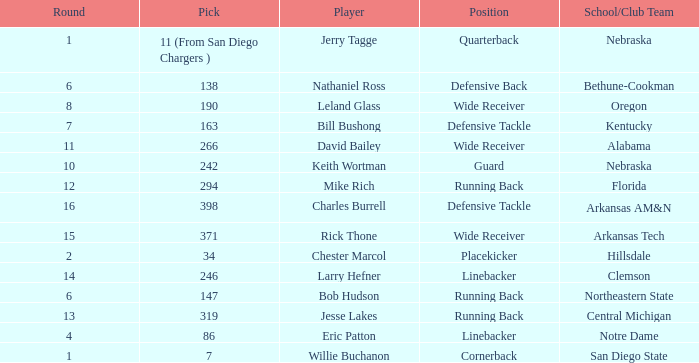Which round has a position that is cornerback? 1.0. 